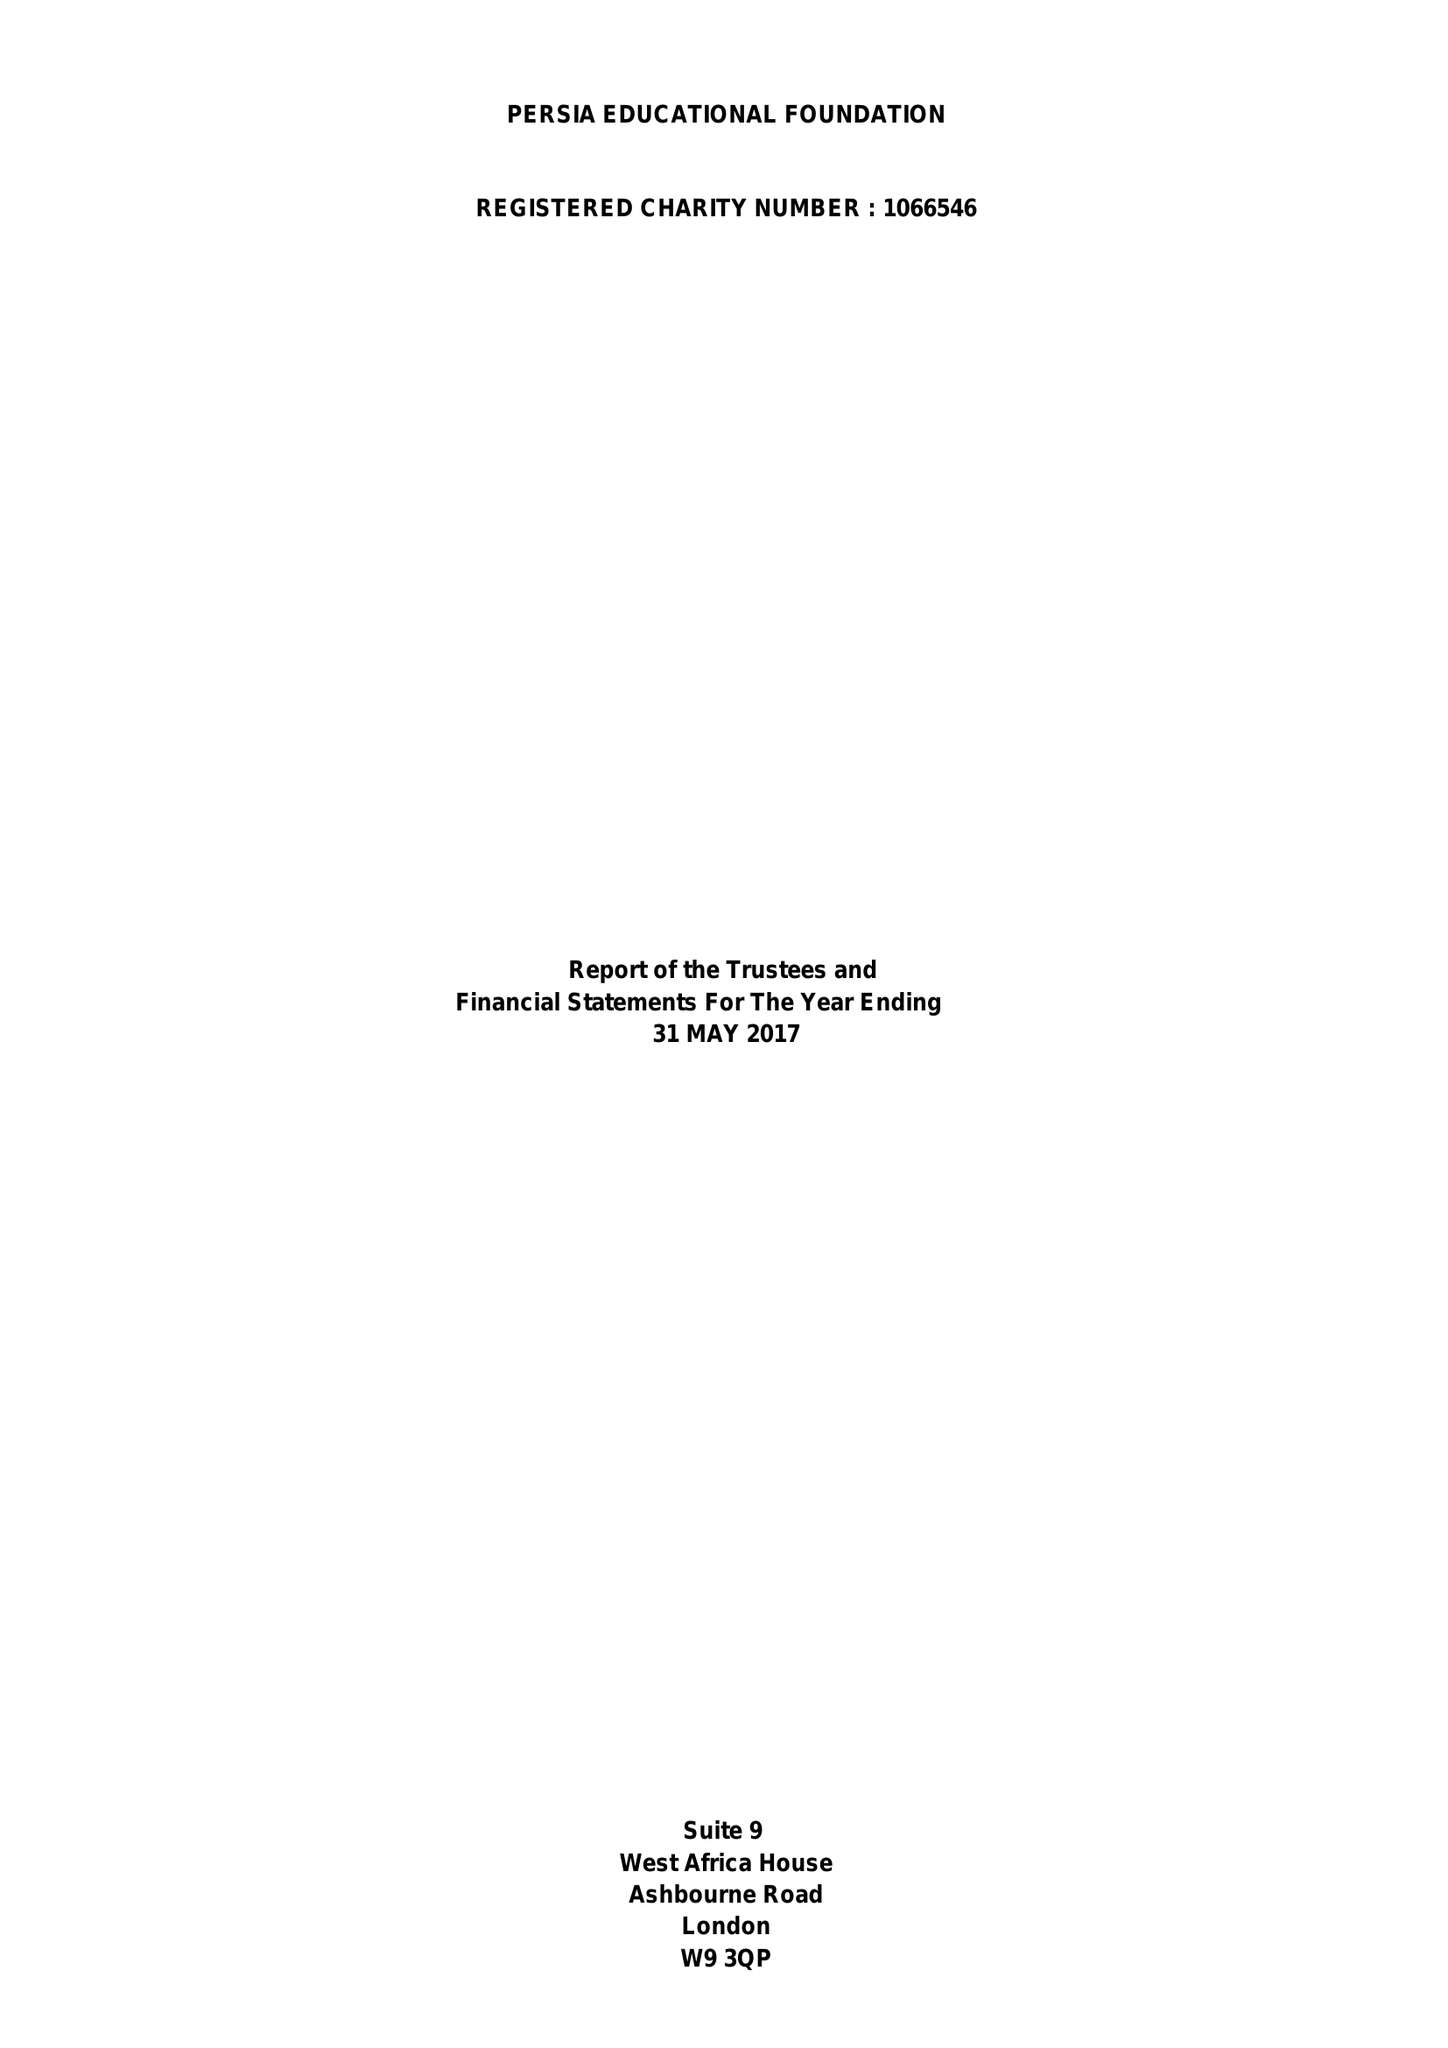What is the value for the address__postcode?
Answer the question using a single word or phrase. W9 3QP 